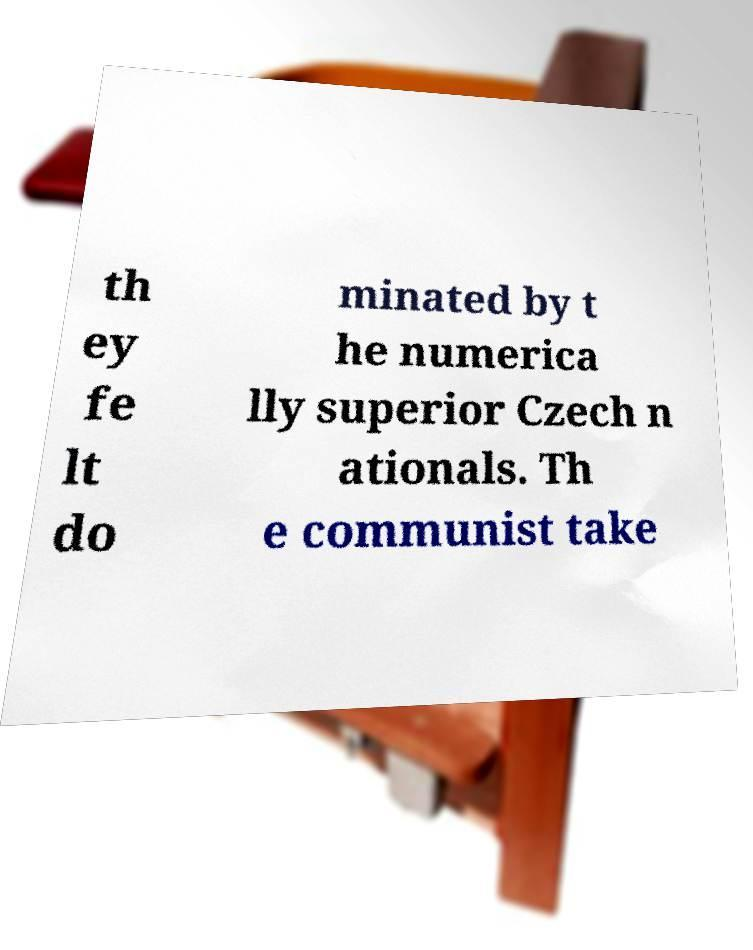There's text embedded in this image that I need extracted. Can you transcribe it verbatim? th ey fe lt do minated by t he numerica lly superior Czech n ationals. Th e communist take 